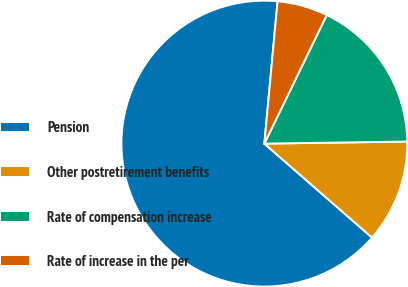<chart> <loc_0><loc_0><loc_500><loc_500><pie_chart><fcel>Pension<fcel>Other postretirement benefits<fcel>Rate of compensation increase<fcel>Rate of increase in the per<nl><fcel>65.05%<fcel>11.65%<fcel>17.58%<fcel>5.72%<nl></chart> 